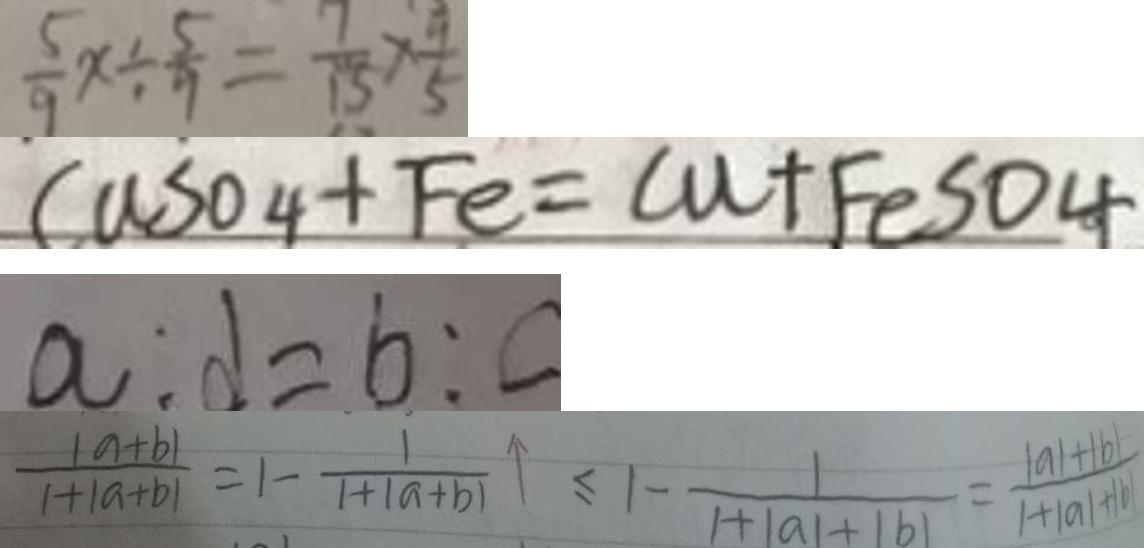Convert formula to latex. <formula><loc_0><loc_0><loc_500><loc_500>\frac { 5 } { 9 } x \div \frac { 5 } { 9 } = \frac { 7 } { 1 5 } \times \frac { 9 } { 5 } 
 C u S O 4 + F e = C u + F e S O 4 
 a : d = b : c 
 \frac { 1 a + b \vert } { 1 + \vert a + b \vert } = 1 - \frac { 1 } { 1 + \vert a + b \vert } \vert \leq 1 - \frac { 1 } { 1 + \vert a \vert + \vert b \vert } = \frac { 1 a \vert + \vert b \vert } { 1 + \vert a \vert + \vert b \vert }</formula> 